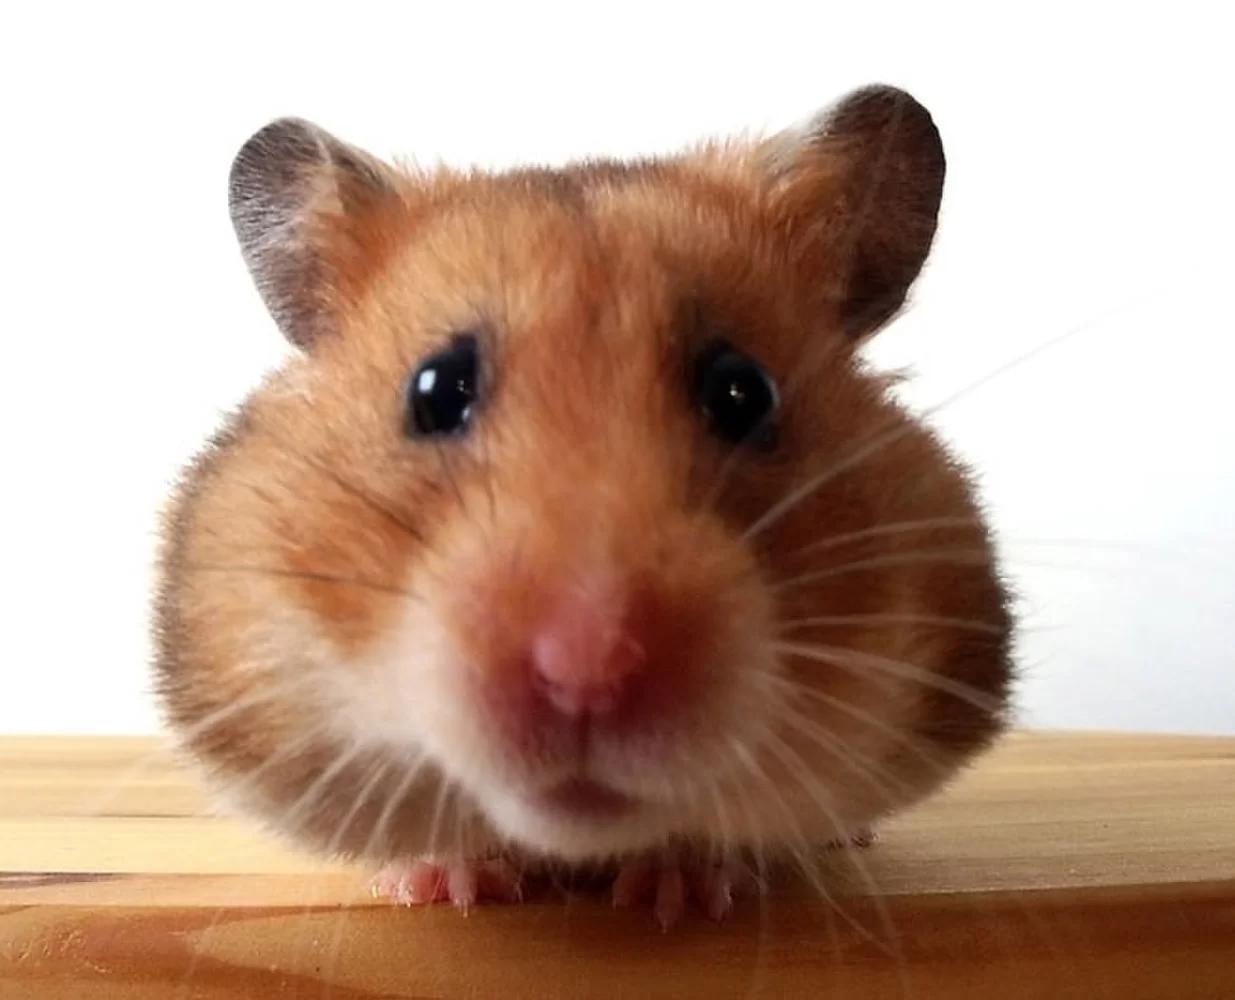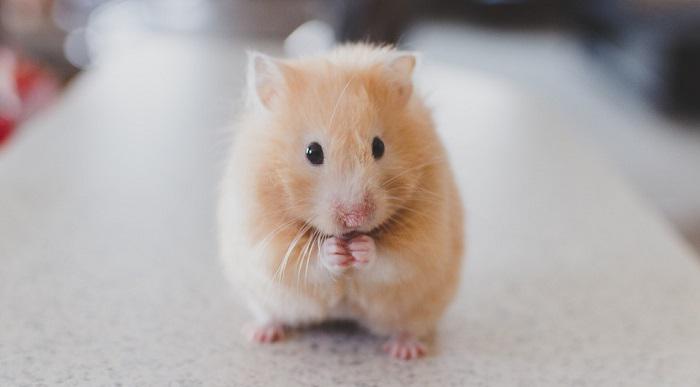The first image is the image on the left, the second image is the image on the right. Analyze the images presented: Is the assertion "All of the hamsters are eating." valid? Answer yes or no. No. The first image is the image on the left, the second image is the image on the right. Examine the images to the left and right. Is the description "The animal in the left image is eating an orange food" accurate? Answer yes or no. No. 